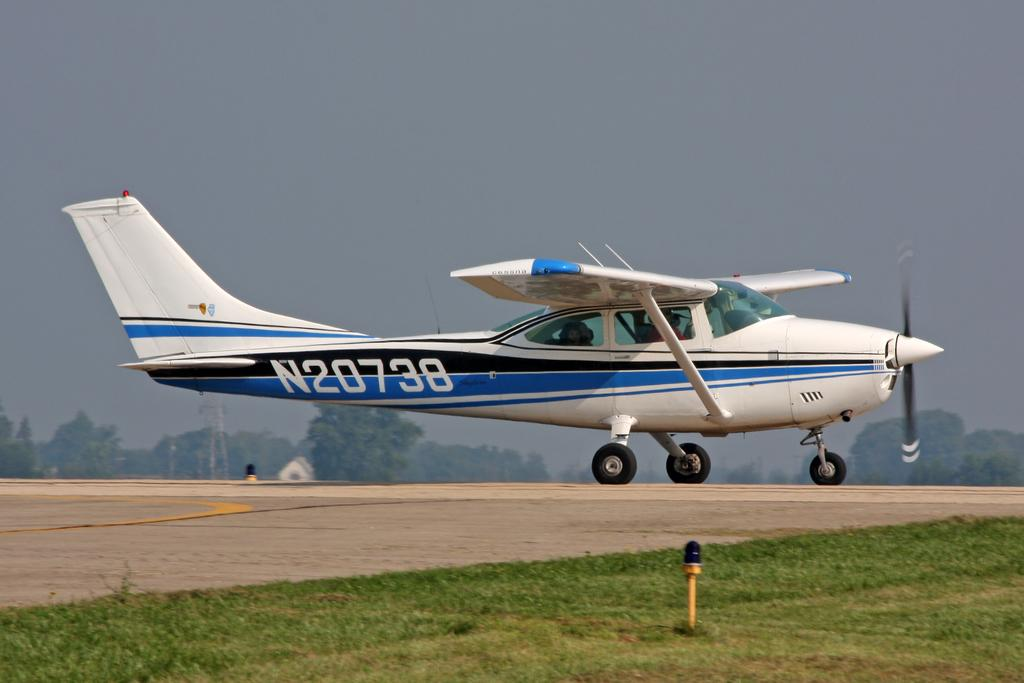<image>
Give a short and clear explanation of the subsequent image. A blue and white plane with the letter N and the numbers 20738 